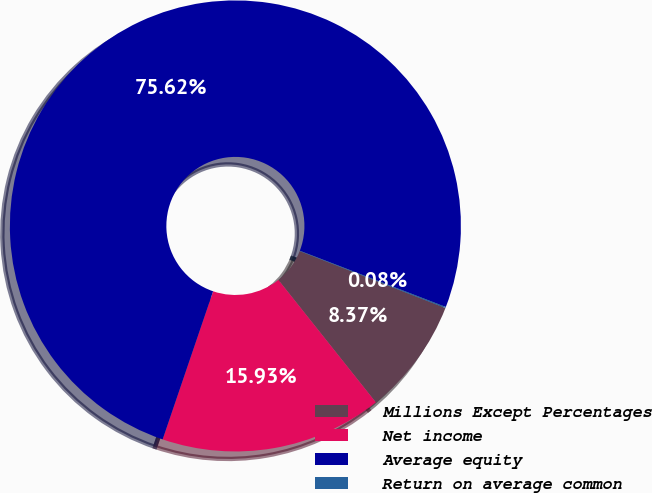Convert chart to OTSL. <chart><loc_0><loc_0><loc_500><loc_500><pie_chart><fcel>Millions Except Percentages<fcel>Net income<fcel>Average equity<fcel>Return on average common<nl><fcel>8.37%<fcel>15.93%<fcel>75.63%<fcel>0.08%<nl></chart> 